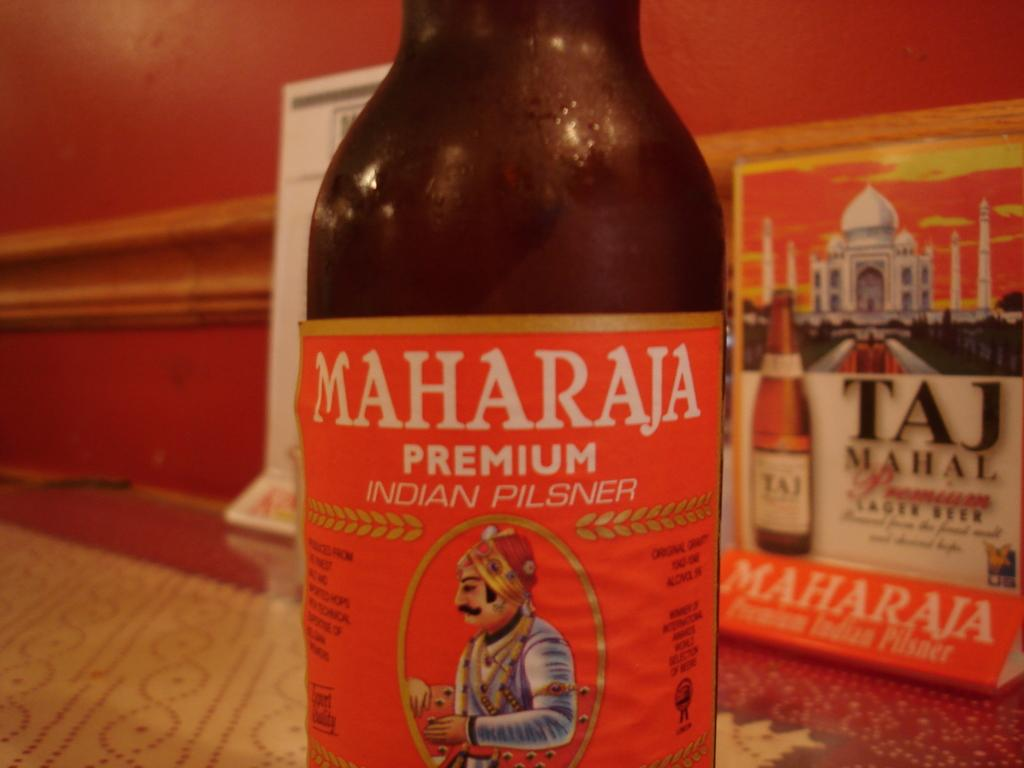Provide a one-sentence caption for the provided image. A bottle of a Maharaja pilsner sits in front of a box of Taj Mahal lager. 